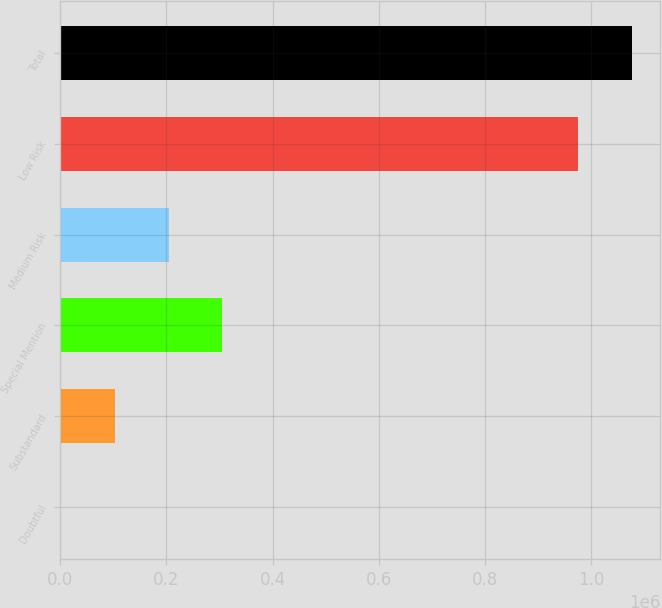Convert chart to OTSL. <chart><loc_0><loc_0><loc_500><loc_500><bar_chart><fcel>Doubtful<fcel>Substandard<fcel>Special Mention<fcel>Medium Risk<fcel>Low Risk<fcel>Total<nl><fcel>688<fcel>102315<fcel>305569<fcel>203942<fcel>975649<fcel>1.07728e+06<nl></chart> 